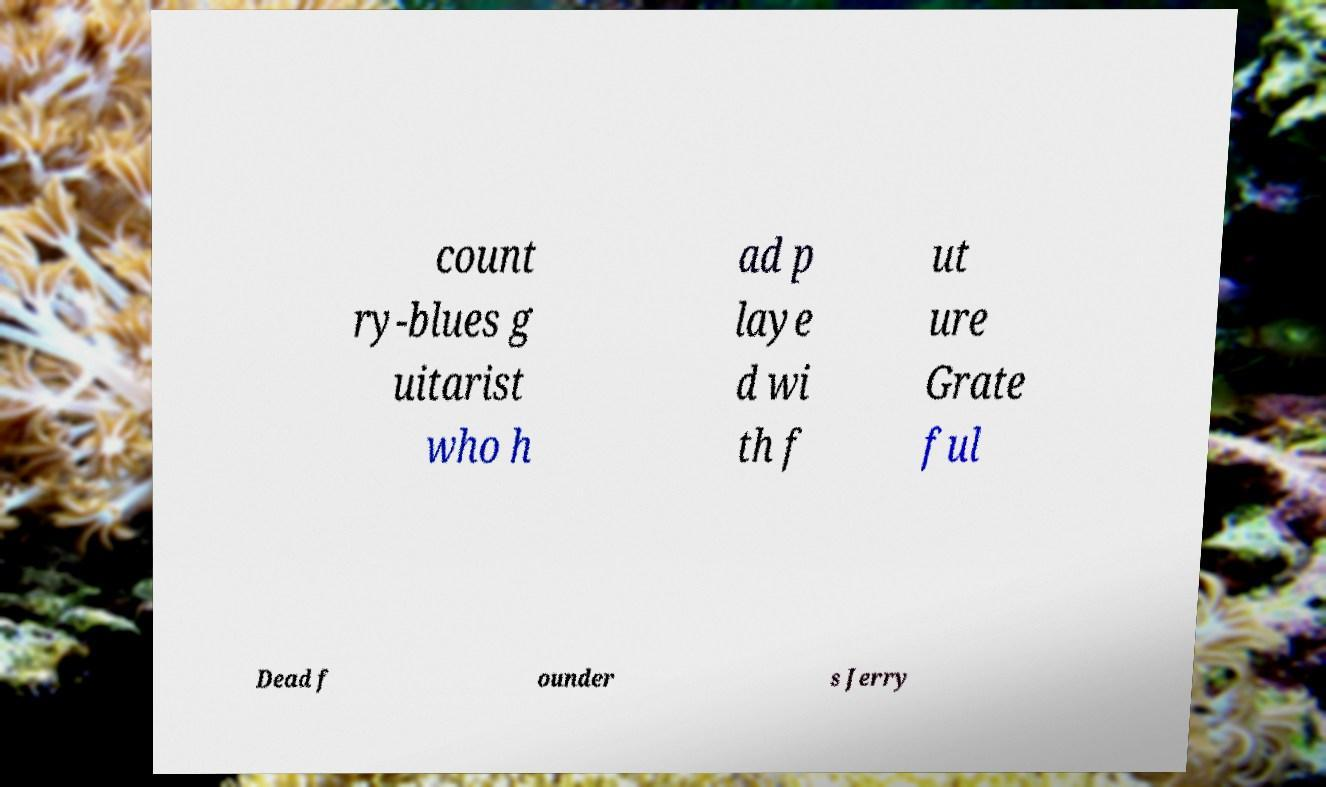Can you accurately transcribe the text from the provided image for me? count ry-blues g uitarist who h ad p laye d wi th f ut ure Grate ful Dead f ounder s Jerry 